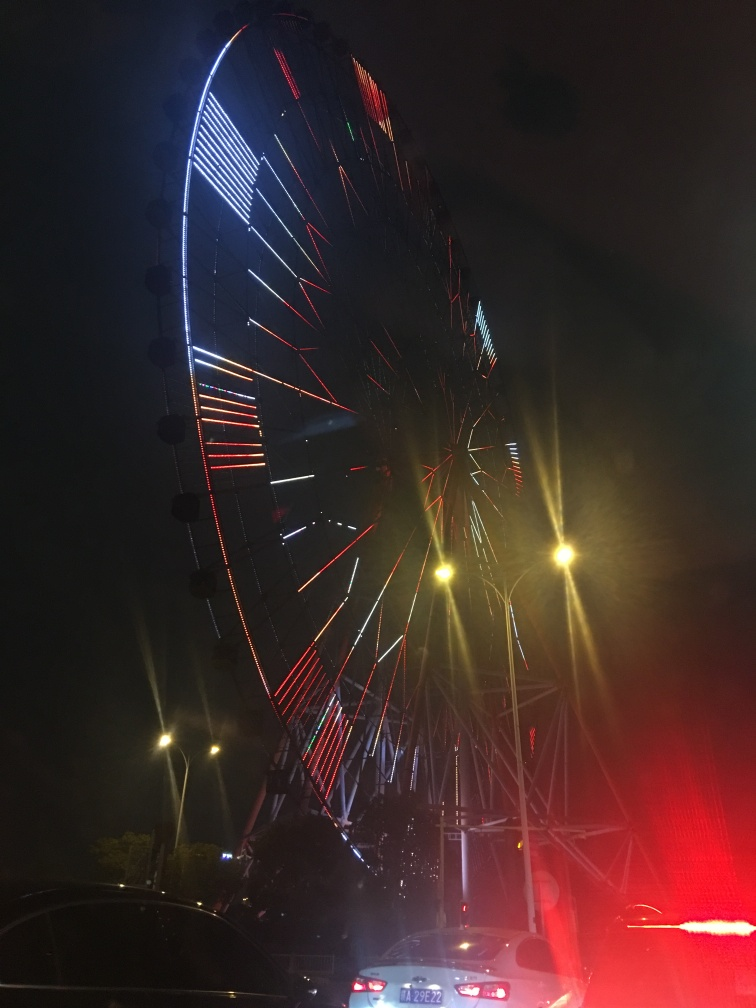Are there any clarity issues? The image shows a ferris wheel at night with illuminated lights. The picture is taken in low light conditions resulting in some visual noise and reduced sharpness. However, the essential elements of the image, like the patterns of the lights and the outline of the ferris wheel, are discernible. 